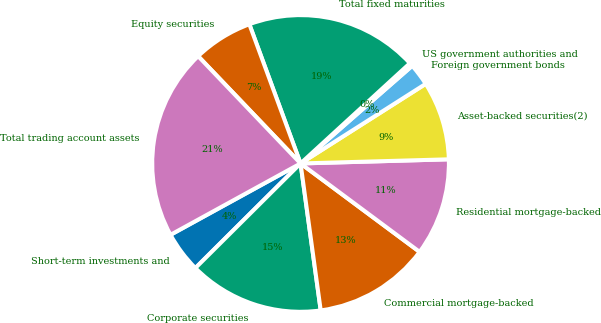Convert chart. <chart><loc_0><loc_0><loc_500><loc_500><pie_chart><fcel>Short-term investments and<fcel>Corporate securities<fcel>Commercial mortgage-backed<fcel>Residential mortgage-backed<fcel>Asset-backed securities(2)<fcel>Foreign government bonds<fcel>US government authorities and<fcel>Total fixed maturities<fcel>Equity securities<fcel>Total trading account assets<nl><fcel>4.47%<fcel>14.71%<fcel>12.66%<fcel>10.61%<fcel>8.57%<fcel>2.42%<fcel>0.37%<fcel>18.8%<fcel>6.52%<fcel>20.85%<nl></chart> 